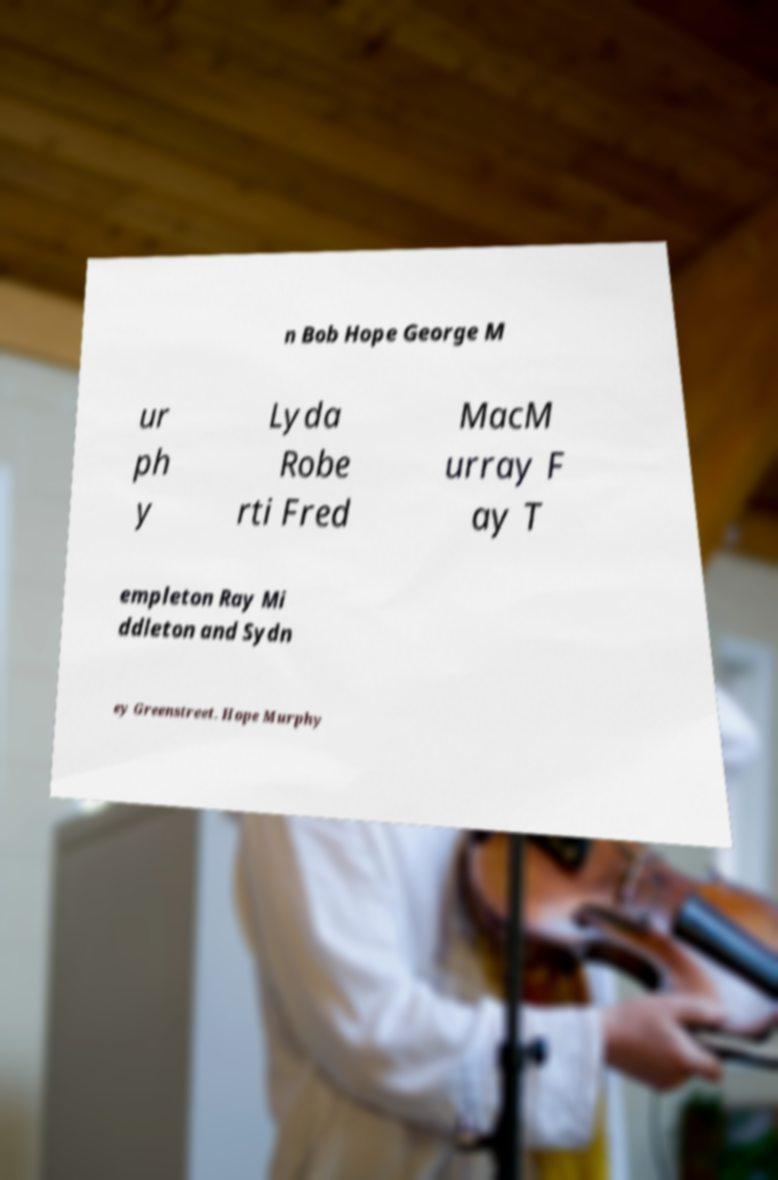Please identify and transcribe the text found in this image. n Bob Hope George M ur ph y Lyda Robe rti Fred MacM urray F ay T empleton Ray Mi ddleton and Sydn ey Greenstreet. Hope Murphy 